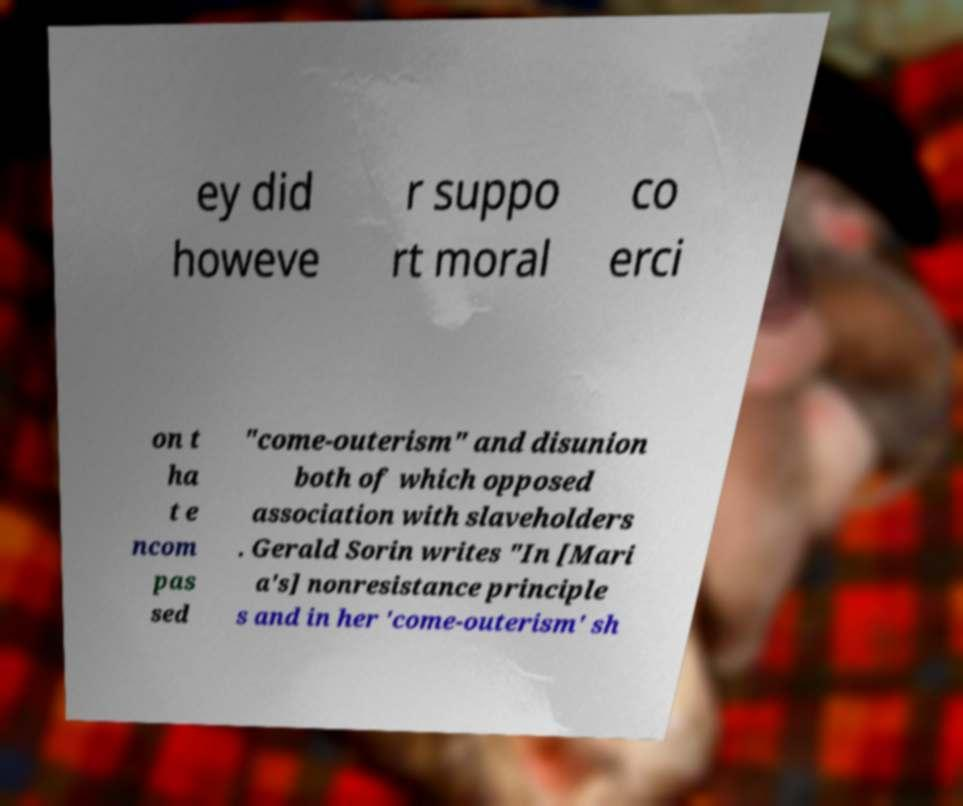Can you accurately transcribe the text from the provided image for me? ey did howeve r suppo rt moral co erci on t ha t e ncom pas sed "come-outerism" and disunion both of which opposed association with slaveholders . Gerald Sorin writes "In [Mari a's] nonresistance principle s and in her 'come-outerism' sh 